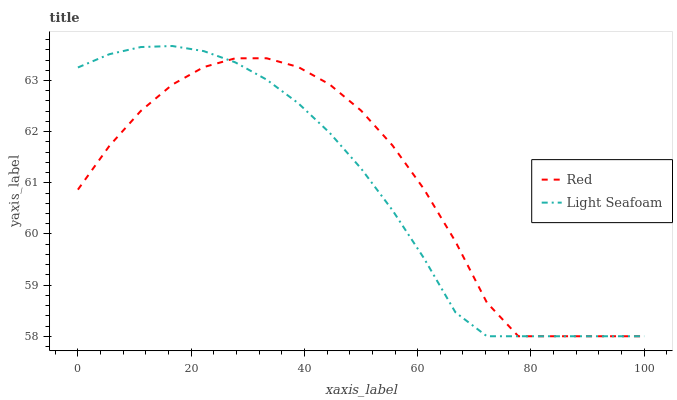Does Light Seafoam have the minimum area under the curve?
Answer yes or no. Yes. Does Red have the maximum area under the curve?
Answer yes or no. Yes. Does Red have the minimum area under the curve?
Answer yes or no. No. Is Light Seafoam the smoothest?
Answer yes or no. Yes. Is Red the roughest?
Answer yes or no. Yes. Is Red the smoothest?
Answer yes or no. No. Does Red have the highest value?
Answer yes or no. No. 